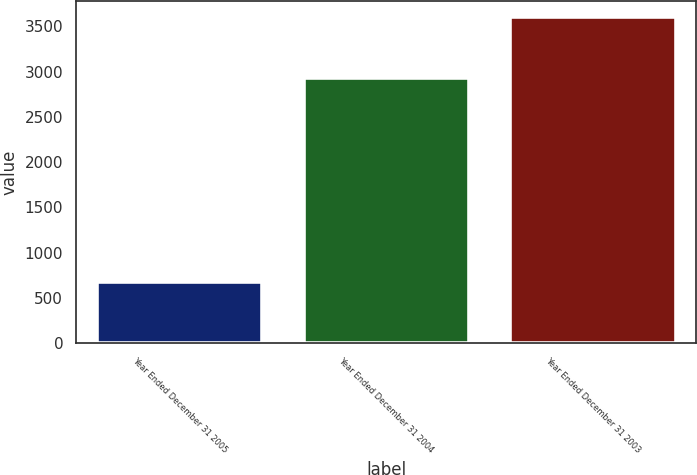Convert chart. <chart><loc_0><loc_0><loc_500><loc_500><bar_chart><fcel>Year Ended December 31 2005<fcel>Year Ended December 31 2004<fcel>Year Ended December 31 2003<nl><fcel>676<fcel>2930<fcel>3599<nl></chart> 